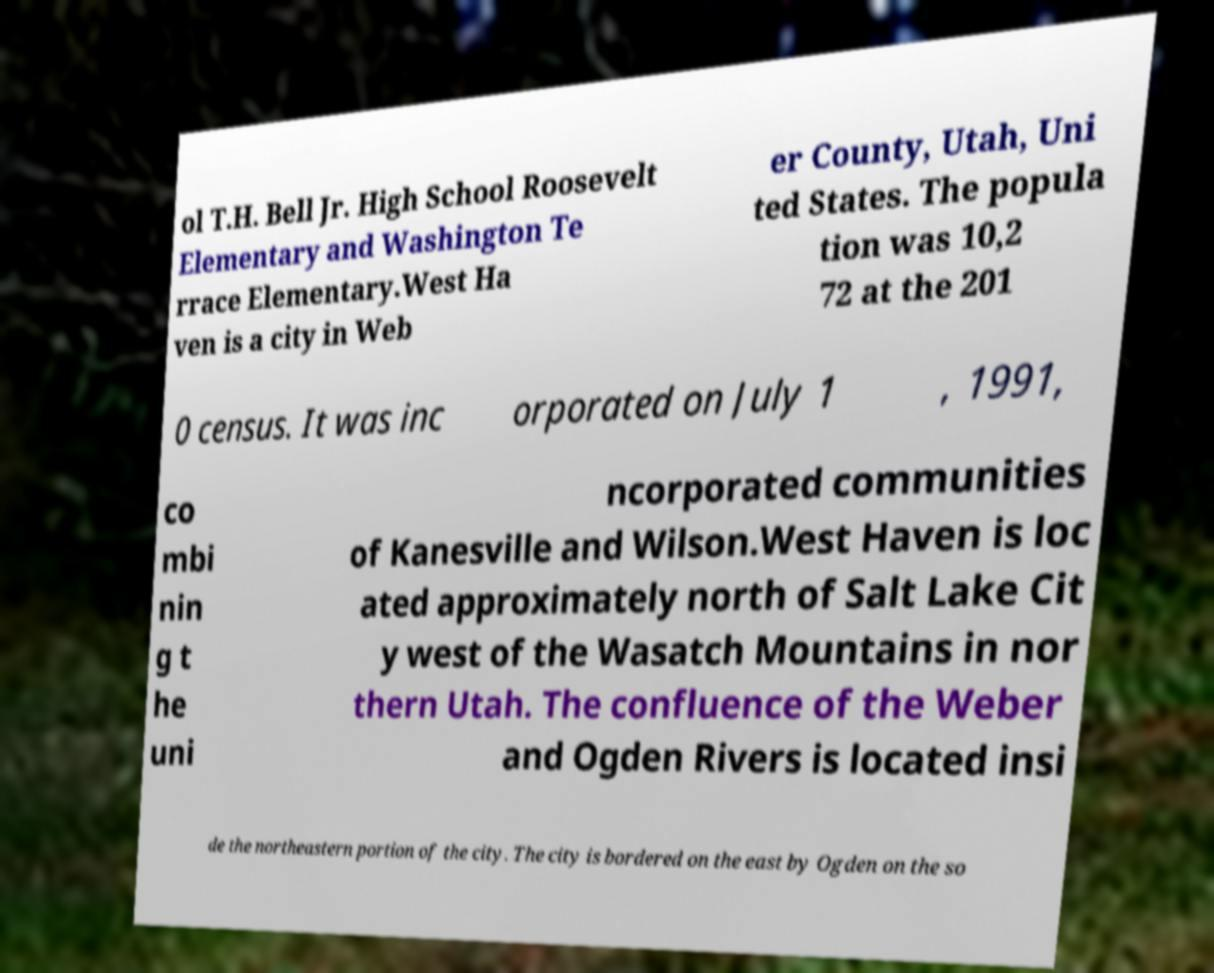Could you assist in decoding the text presented in this image and type it out clearly? ol T.H. Bell Jr. High School Roosevelt Elementary and Washington Te rrace Elementary.West Ha ven is a city in Web er County, Utah, Uni ted States. The popula tion was 10,2 72 at the 201 0 census. It was inc orporated on July 1 , 1991, co mbi nin g t he uni ncorporated communities of Kanesville and Wilson.West Haven is loc ated approximately north of Salt Lake Cit y west of the Wasatch Mountains in nor thern Utah. The confluence of the Weber and Ogden Rivers is located insi de the northeastern portion of the city. The city is bordered on the east by Ogden on the so 